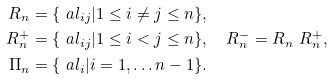<formula> <loc_0><loc_0><loc_500><loc_500>R _ { n } & = \{ \ a l _ { i j } | 1 \leq i \neq j \leq { n } \} , \\ R _ { n } ^ { + } & = \{ \ a l _ { i j } | 1 \leq i < j \leq { n } \} , \quad R _ { n } ^ { - } = R _ { n } \ R _ { n } ^ { + } , \\ \Pi _ { n } & = \{ \ a l _ { i } | i = 1 , \dots { n } - 1 \} .</formula> 